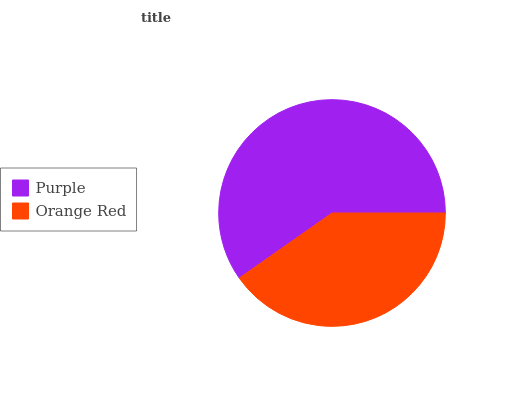Is Orange Red the minimum?
Answer yes or no. Yes. Is Purple the maximum?
Answer yes or no. Yes. Is Orange Red the maximum?
Answer yes or no. No. Is Purple greater than Orange Red?
Answer yes or no. Yes. Is Orange Red less than Purple?
Answer yes or no. Yes. Is Orange Red greater than Purple?
Answer yes or no. No. Is Purple less than Orange Red?
Answer yes or no. No. Is Purple the high median?
Answer yes or no. Yes. Is Orange Red the low median?
Answer yes or no. Yes. Is Orange Red the high median?
Answer yes or no. No. Is Purple the low median?
Answer yes or no. No. 